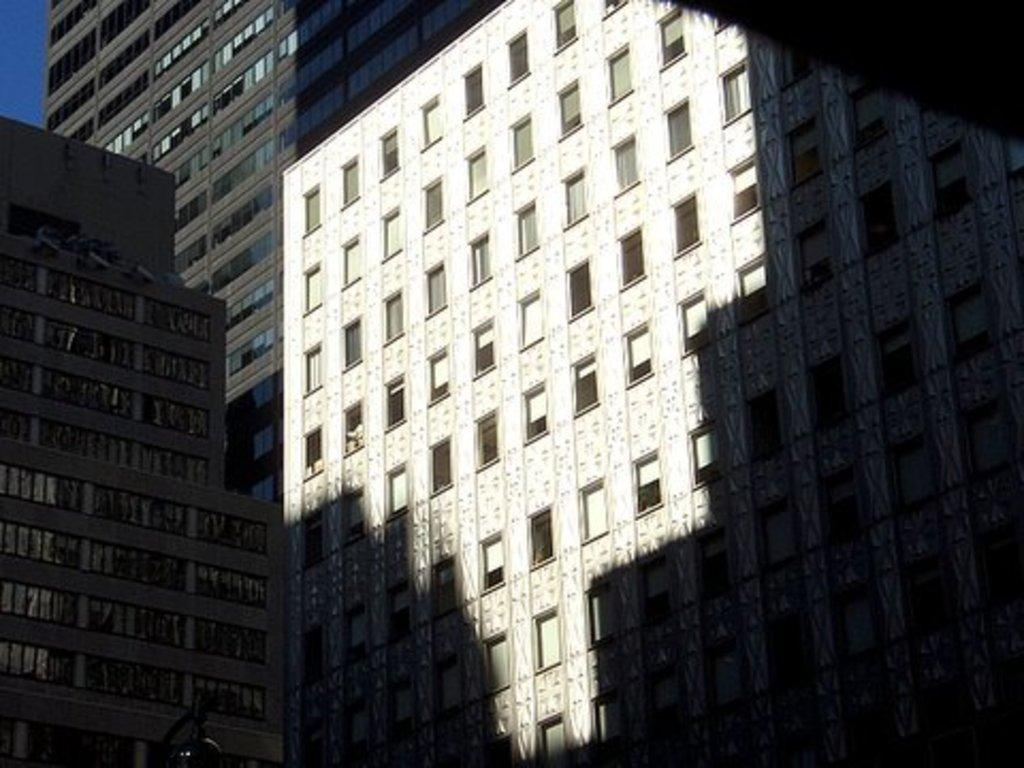What type of structures can be seen in the image? There are buildings in the image. What type of feather can be seen on the roof of the buildings in the image? There is no feather present on the roof of the buildings in the image. What type of grain is being harvested in the fields surrounding the buildings in the image? There are no fields or grain visible in the image; it only shows buildings. 